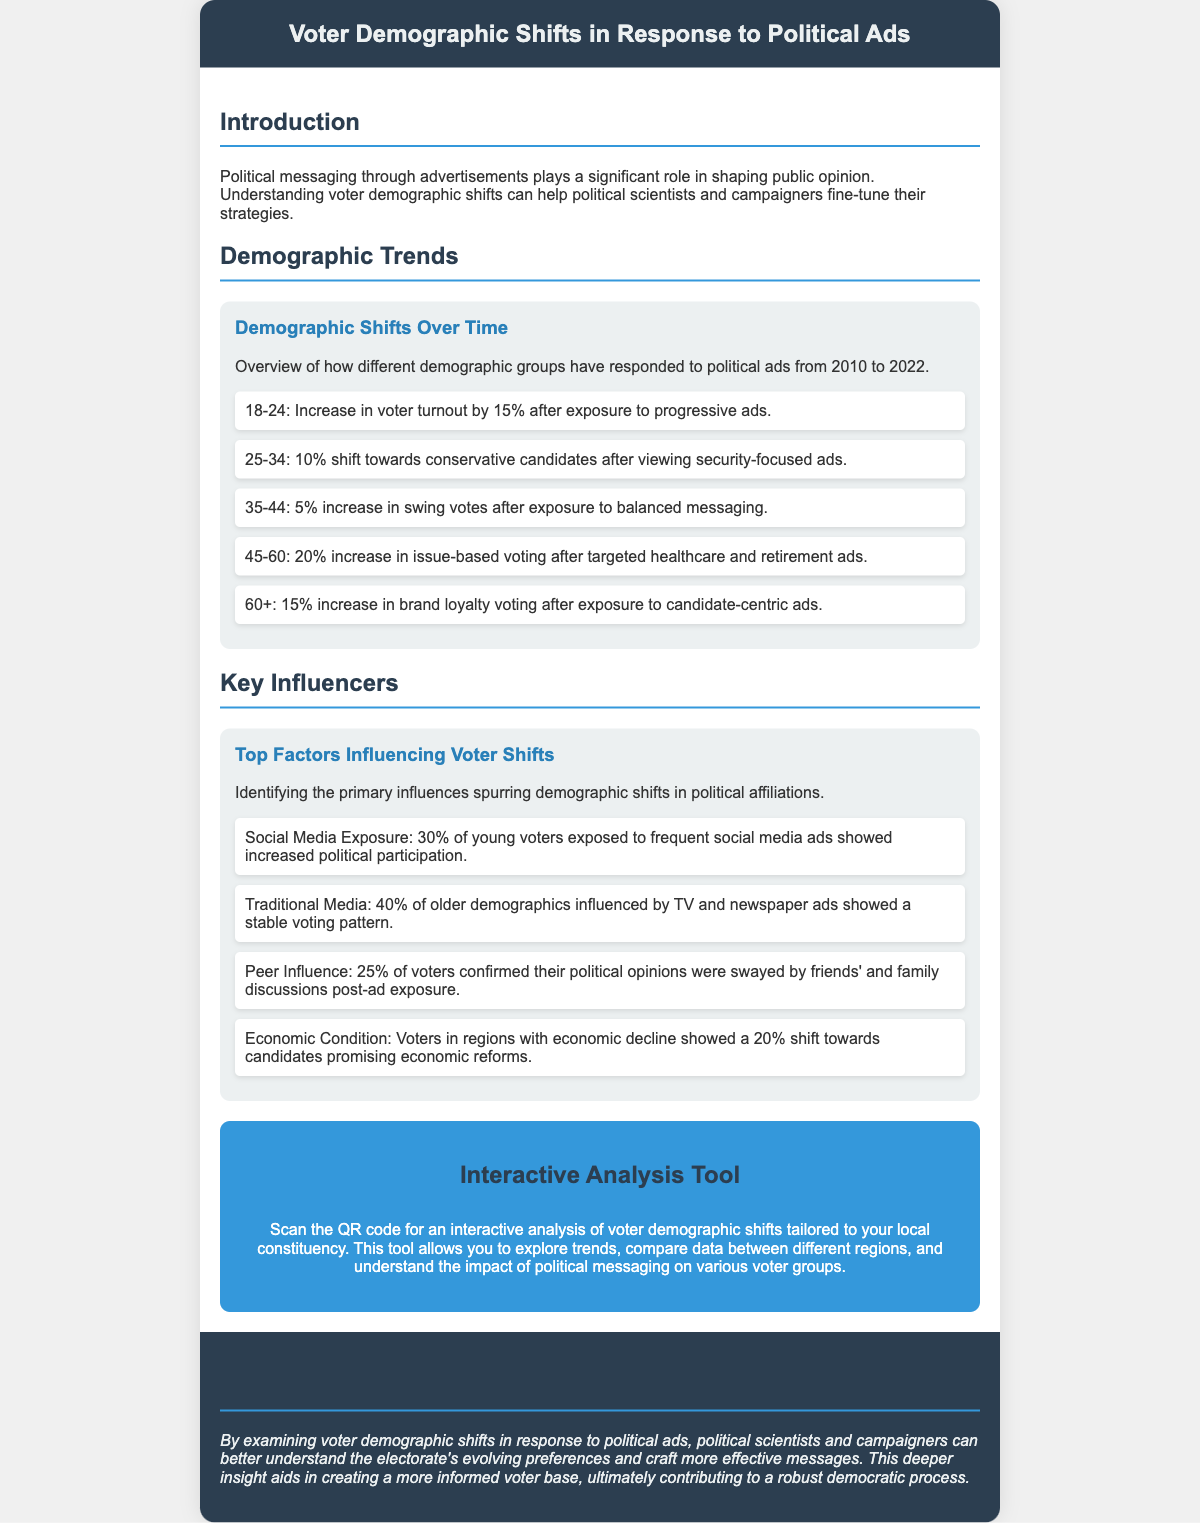What was the increase in voter turnout for ages 18-24 after exposure to progressive ads? The document states that there was a 15% increase in voter turnout for the 18-24 age group after exposure to progressive ads.
Answer: 15% What demographic had a 20% increase in issue-based voting? According to the document, the 45-60 age demographic saw a 20% increase in issue-based voting after targeted ads.
Answer: 45-60 What was the influence of social media exposure on young voters? The document indicates that 30% of young voters exposed to frequent social media ads showed increased political participation.
Answer: 30% What is the main focus of the interactive analysis tool? The interactive analysis tool is designed to allow users to explore trends, compare data between different regions, and understand the impact of political messaging on various voter groups.
Answer: Explore trends How does age influence voter responses to ads according to the document? The document indicates that different age groups have varied responses, such as 15% for 18-24 and 20% for 45-60 towards specific ad types.
Answer: Varied responses 